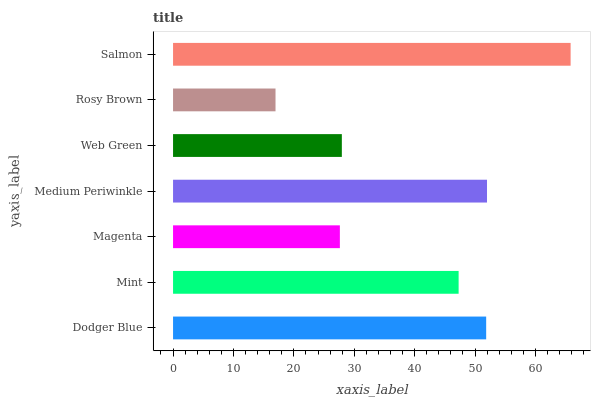Is Rosy Brown the minimum?
Answer yes or no. Yes. Is Salmon the maximum?
Answer yes or no. Yes. Is Mint the minimum?
Answer yes or no. No. Is Mint the maximum?
Answer yes or no. No. Is Dodger Blue greater than Mint?
Answer yes or no. Yes. Is Mint less than Dodger Blue?
Answer yes or no. Yes. Is Mint greater than Dodger Blue?
Answer yes or no. No. Is Dodger Blue less than Mint?
Answer yes or no. No. Is Mint the high median?
Answer yes or no. Yes. Is Mint the low median?
Answer yes or no. Yes. Is Salmon the high median?
Answer yes or no. No. Is Web Green the low median?
Answer yes or no. No. 